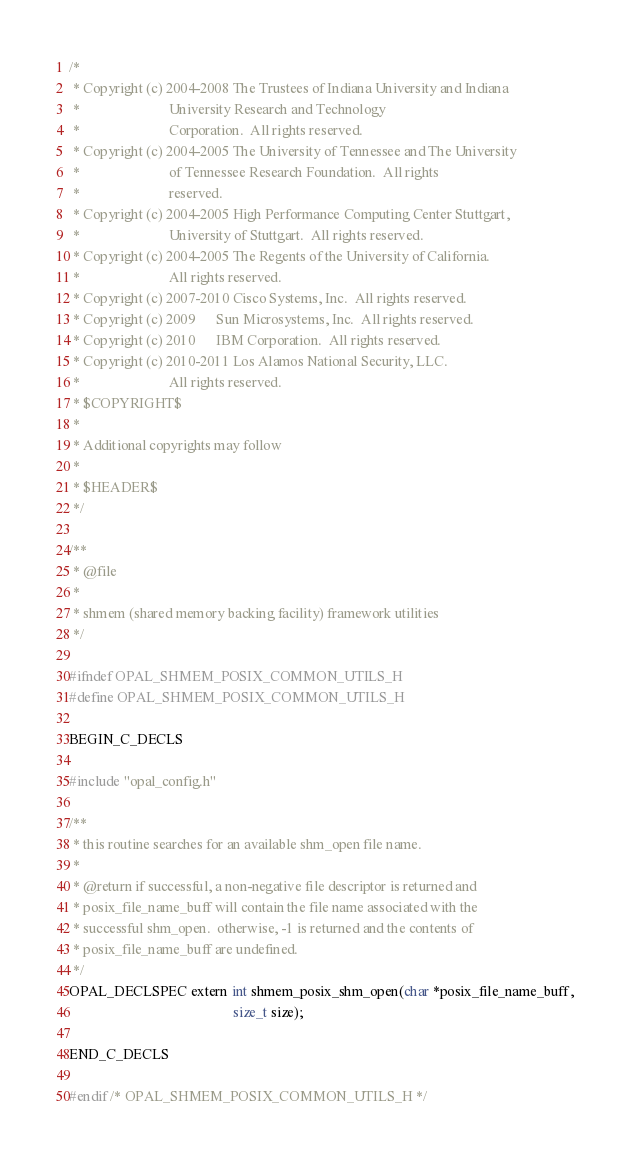Convert code to text. <code><loc_0><loc_0><loc_500><loc_500><_C_>/*
 * Copyright (c) 2004-2008 The Trustees of Indiana University and Indiana
 *                         University Research and Technology
 *                         Corporation.  All rights reserved.
 * Copyright (c) 2004-2005 The University of Tennessee and The University
 *                         of Tennessee Research Foundation.  All rights
 *                         reserved.
 * Copyright (c) 2004-2005 High Performance Computing Center Stuttgart,
 *                         University of Stuttgart.  All rights reserved.
 * Copyright (c) 2004-2005 The Regents of the University of California.
 *                         All rights reserved.
 * Copyright (c) 2007-2010 Cisco Systems, Inc.  All rights reserved.
 * Copyright (c) 2009      Sun Microsystems, Inc.  All rights reserved.
 * Copyright (c) 2010      IBM Corporation.  All rights reserved.
 * Copyright (c) 2010-2011 Los Alamos National Security, LLC.
 *                         All rights reserved.
 * $COPYRIGHT$
 *
 * Additional copyrights may follow
 *
 * $HEADER$
 */

/**
 * @file
 *
 * shmem (shared memory backing facility) framework utilities
 */

#ifndef OPAL_SHMEM_POSIX_COMMON_UTILS_H
#define OPAL_SHMEM_POSIX_COMMON_UTILS_H

BEGIN_C_DECLS

#include "opal_config.h"

/**
 * this routine searches for an available shm_open file name.
 *
 * @return if successful, a non-negative file descriptor is returned and
 * posix_file_name_buff will contain the file name associated with the
 * successful shm_open.  otherwise, -1 is returned and the contents of
 * posix_file_name_buff are undefined.
 */
OPAL_DECLSPEC extern int shmem_posix_shm_open(char *posix_file_name_buff,
                                              size_t size);

END_C_DECLS

#endif /* OPAL_SHMEM_POSIX_COMMON_UTILS_H */
</code> 